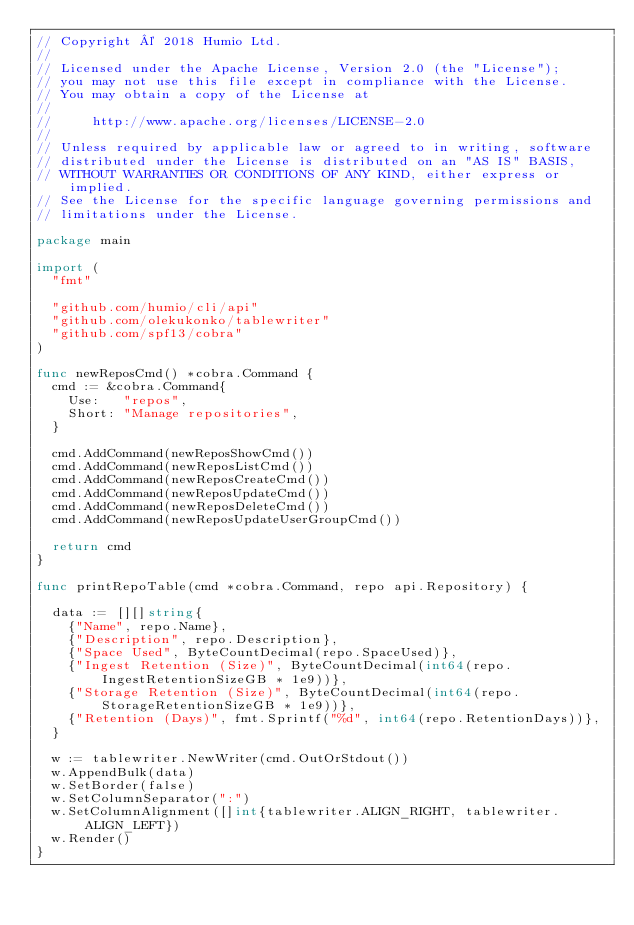Convert code to text. <code><loc_0><loc_0><loc_500><loc_500><_Go_>// Copyright © 2018 Humio Ltd.
//
// Licensed under the Apache License, Version 2.0 (the "License");
// you may not use this file except in compliance with the License.
// You may obtain a copy of the License at
//
//     http://www.apache.org/licenses/LICENSE-2.0
//
// Unless required by applicable law or agreed to in writing, software
// distributed under the License is distributed on an "AS IS" BASIS,
// WITHOUT WARRANTIES OR CONDITIONS OF ANY KIND, either express or implied.
// See the License for the specific language governing permissions and
// limitations under the License.

package main

import (
	"fmt"

	"github.com/humio/cli/api"
	"github.com/olekukonko/tablewriter"
	"github.com/spf13/cobra"
)

func newReposCmd() *cobra.Command {
	cmd := &cobra.Command{
		Use:   "repos",
		Short: "Manage repositories",
	}

	cmd.AddCommand(newReposShowCmd())
	cmd.AddCommand(newReposListCmd())
	cmd.AddCommand(newReposCreateCmd())
	cmd.AddCommand(newReposUpdateCmd())
	cmd.AddCommand(newReposDeleteCmd())
	cmd.AddCommand(newReposUpdateUserGroupCmd())

	return cmd
}

func printRepoTable(cmd *cobra.Command, repo api.Repository) {

	data := [][]string{
		{"Name", repo.Name},
		{"Description", repo.Description},
		{"Space Used", ByteCountDecimal(repo.SpaceUsed)},
		{"Ingest Retention (Size)", ByteCountDecimal(int64(repo.IngestRetentionSizeGB * 1e9))},
		{"Storage Retention (Size)", ByteCountDecimal(int64(repo.StorageRetentionSizeGB * 1e9))},
		{"Retention (Days)", fmt.Sprintf("%d", int64(repo.RetentionDays))},
	}

	w := tablewriter.NewWriter(cmd.OutOrStdout())
	w.AppendBulk(data)
	w.SetBorder(false)
	w.SetColumnSeparator(":")
	w.SetColumnAlignment([]int{tablewriter.ALIGN_RIGHT, tablewriter.ALIGN_LEFT})
	w.Render()
}
</code> 